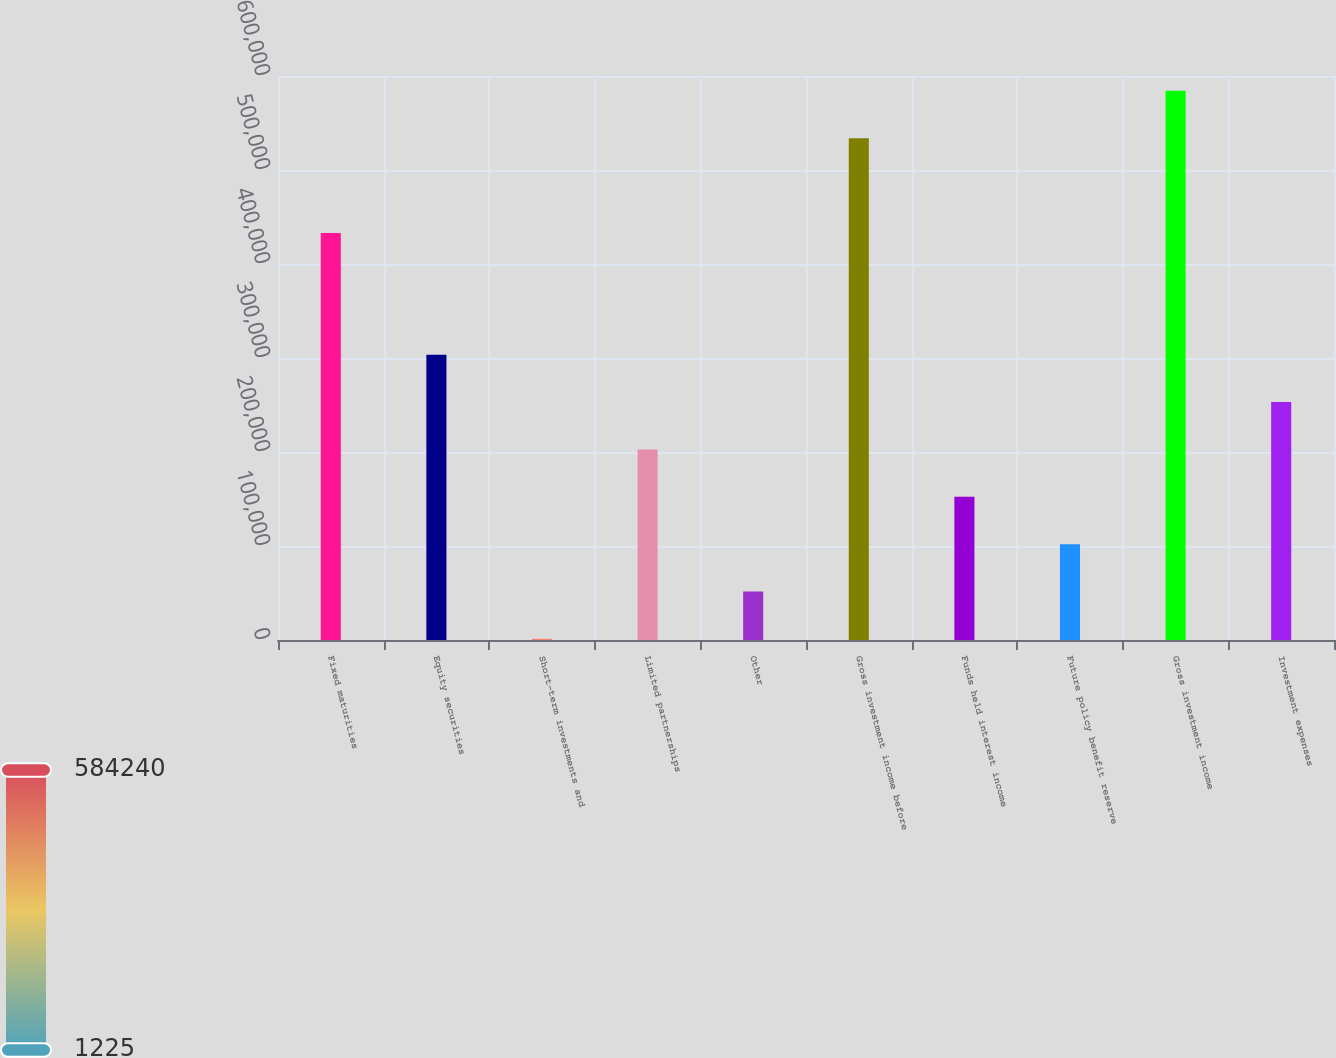Convert chart to OTSL. <chart><loc_0><loc_0><loc_500><loc_500><bar_chart><fcel>Fixed maturities<fcel>Equity securities<fcel>Short-term investments and<fcel>Limited partnerships<fcel>Other<fcel>Gross investment income before<fcel>Funds held interest income<fcel>Future policy benefit reserve<fcel>Gross investment income<fcel>Investment expenses<nl><fcel>433097<fcel>303510<fcel>1225<fcel>202749<fcel>51605.9<fcel>533859<fcel>152368<fcel>101987<fcel>584240<fcel>253130<nl></chart> 